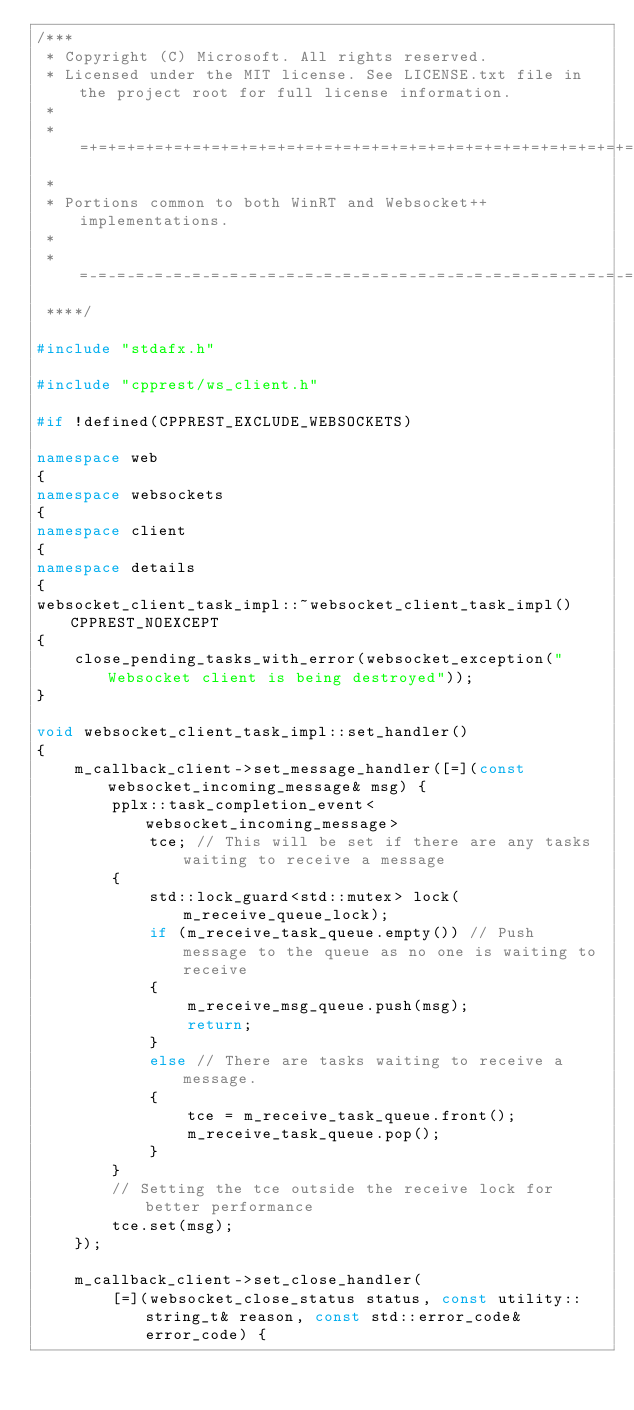Convert code to text. <code><loc_0><loc_0><loc_500><loc_500><_C++_>/***
 * Copyright (C) Microsoft. All rights reserved.
 * Licensed under the MIT license. See LICENSE.txt file in the project root for full license information.
 *
 * =+=+=+=+=+=+=+=+=+=+=+=+=+=+=+=+=+=+=+=+=+=+=+=+=+=+=+=+=+=+=+=+=+=+=+=+=+=+=+=+=+=+=+=+=+=+=+=+=+
 *
 * Portions common to both WinRT and Websocket++ implementations.
 *
 * =-=-=-=-=-=-=-=-=-=-=-=-=-=-=-=-=-=-=-=-=-=-=-=-=-=-=-=-=-=-=-=-=-=-=-=-=-=-=-=-=-=-=-=-=-=-=-=-=-
 ****/

#include "stdafx.h"

#include "cpprest/ws_client.h"

#if !defined(CPPREST_EXCLUDE_WEBSOCKETS)

namespace web
{
namespace websockets
{
namespace client
{
namespace details
{
websocket_client_task_impl::~websocket_client_task_impl() CPPREST_NOEXCEPT
{
    close_pending_tasks_with_error(websocket_exception("Websocket client is being destroyed"));
}

void websocket_client_task_impl::set_handler()
{
    m_callback_client->set_message_handler([=](const websocket_incoming_message& msg) {
        pplx::task_completion_event<websocket_incoming_message>
            tce; // This will be set if there are any tasks waiting to receive a message
        {
            std::lock_guard<std::mutex> lock(m_receive_queue_lock);
            if (m_receive_task_queue.empty()) // Push message to the queue as no one is waiting to receive
            {
                m_receive_msg_queue.push(msg);
                return;
            }
            else // There are tasks waiting to receive a message.
            {
                tce = m_receive_task_queue.front();
                m_receive_task_queue.pop();
            }
        }
        // Setting the tce outside the receive lock for better performance
        tce.set(msg);
    });

    m_callback_client->set_close_handler(
        [=](websocket_close_status status, const utility::string_t& reason, const std::error_code& error_code) {</code> 